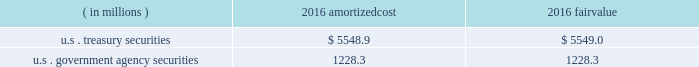Each clearing firm is required to deposit and maintain balances in the form of cash , u.s .
Government securities , certain foreign government securities , bank letters of credit or other approved investments to satisfy performance bond and guaranty fund requirements .
All non-cash deposits are marked-to-market and haircut on a daily basis .
Securities deposited by the clearing firms are not reflected in the consolidated financial statements and the clearing house does not earn any interest on these deposits .
These balances may fluctuate significantly over time due to investment choices available to clearing firms and changes in the amount of contributions required .
In addition , the rules and regulations of cbot require that collateral be provided for delivery of physical commodities , maintenance of capital requirements and deposits on pending arbitration matters .
To satisfy these requirements , clearing firms that have accounts that trade certain cbot products have deposited cash , u.s .
Treasury securities or letters of credit .
The clearing house marks-to-market open positions at least once a day ( twice a day for futures and options contracts ) , and require payment from clearing firms whose positions have lost value and make payments to clearing firms whose positions have gained value .
The clearing house has the capability to mark-to-market more frequently as market conditions warrant .
Under the extremely unlikely scenario of simultaneous default by every clearing firm who has open positions with unrealized losses , the maximum exposure related to positions other than credit default and interest rate swap contracts would be one half day of changes in fair value of all open positions , before considering the clearing houses 2019 ability to access defaulting clearing firms 2019 collateral deposits .
For cleared credit default swap and interest rate swap contracts , the maximum exposure related to cme 2019s guarantee would be one full day of changes in fair value of all open positions , before considering cme 2019s ability to access defaulting clearing firms 2019 collateral .
During 2017 , the clearing house transferred an average of approximately $ 2.4 billion a day through the clearing system for settlement from clearing firms whose positions had lost value to clearing firms whose positions had gained value .
The clearing house reduces the guarantee exposure through initial and maintenance performance bond requirements and mandatory guaranty fund contributions .
The company believes that the guarantee liability is immaterial and therefore has not recorded any liability at december 31 , 2017 .
At december 31 , 2016 , performance bond and guaranty fund contribution assets on the consolidated balance sheets included cash as well as u.s .
Treasury and u.s .
Government agency securities with maturity dates of 90 days or less .
The u.s .
Treasury and u.s .
Government agency securities were purchased by cme , at its discretion , using cash collateral .
The benefits , including interest earned , and risks of ownership accrue to cme .
Interest earned is included in investment income on the consolidated statements of income .
There were no u.s .
Treasury and u.s .
Government agency securities held at december 31 , 2017 .
The amortized cost and fair value of these securities at december 31 , 2016 were as follows : ( in millions ) amortized .
Cme has been designated as a systemically important financial market utility by the financial stability oversight council and maintains a cash account at the federal reserve bank of chicago .
At december 31 , 2017 and december 31 , 2016 , cme maintained $ 34.2 billion and $ 6.2 billion , respectively , within the cash account at the federal reserve bank of chicago .
Clearing firms , at their option , may instruct cme to deposit the cash held by cme into one of the ief programs .
The total principal in the ief programs was $ 1.1 billion at december 31 , 2017 and $ 6.8 billion at december 31 .
What was the average balance within the cash account at the federal reserve bank of chicago for december 31 , 2017 and december 31 , 2016 , in billions? 
Computations: ((34.2 + 6.2) / 2)
Answer: 20.2. 